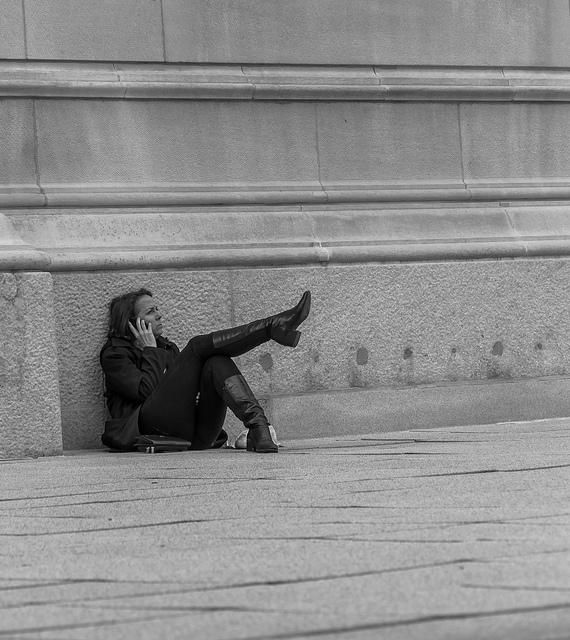What other people are known to sit in locations like this in this position? homeless people 